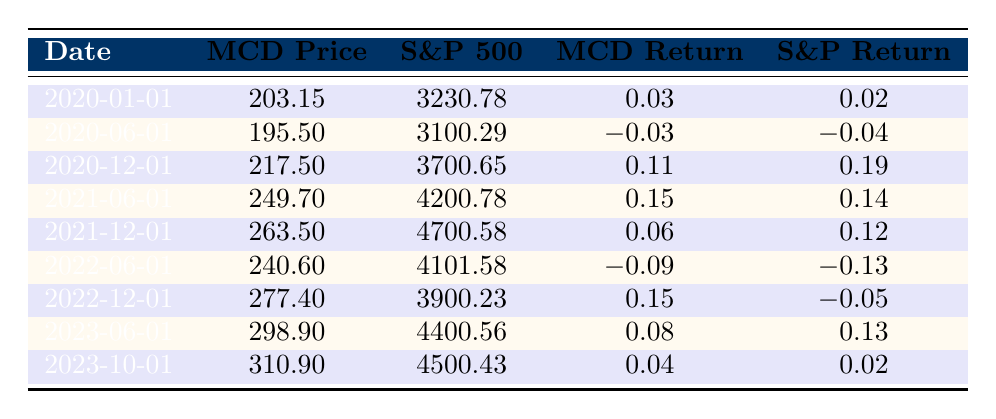What was the stock price of McDonald's on June 1, 2020? The table shows that McDonald's stock price on June 1, 2020, is listed under the respective date, which is 195.50.
Answer: 195.50 What was the S&P 500 index value on December 1, 2021? Looking at the table, the S&P 500 index value on December 1, 2021, is shown as 4700.58.
Answer: 4700.58 Between January 2020 and June 2021, which had a higher return, McDonald's or the S&P 500? For the relevant period, McDonald's returns were 0.03 (Jan 2020) and 0.15 (Jun 2021), while S&P returns were 0.02 and 0.14 respectively. McDonald's had higher returns in both instances.
Answer: McDonald's What was the difference in McDonald's stock price between December 1, 2020, and June 1, 2022? McDonald's stock prices were 217.50 on December 1, 2020, and 240.60 on June 1, 2022. The difference is 240.60 - 217.50 = 23.10.
Answer: 23.10 What was the average return of McDonald's from January 2020 to December 2022? The returns for the periods are: 0.03, -0.03, 0.11, 0.15, 0.06, -0.09, 0.15. Summing these gives 0.03 + (-0.03) + 0.11 + 0.15 + 0.06 + (-0.09) + 0.15 = 0.38. Dividing by the total periods (7) gives an average return of 0.38 / 7 = 0.0542857, approximately 0.05.
Answer: 0.05 Did McDonald's stock price consistently rise from June 2021 to October 2023? From the table, the prices show an increasing trend: 249.70 (June 2021), 263.50 (December 2021), 240.60 (June 2022 - a drop), 277.40 (December 2022), 298.90 (June 2023), 310.90 (October 2023). There was a drop in June 2022, indicating inconsistency.
Answer: No Which month had the highest percentage return for McDonald's stock? Calculating returns shows the highest return was on June 1, 2021, with 0.15 (15%). This is higher than the other monthly returns listed.
Answer: June 1, 2021 What was the total percentage change in McDonald's stock price from January 2020 to October 2023? The stock price increased from 203.15 in January 2020 to 310.90 in October 2023. The change in price is 310.90 - 203.15 = 107.75. The percentage change is (107.75 / 203.15) * 100 ≈ 52.97%.
Answer: 52.97% During which period did McDonald's stock experience a decline, and how much was the decline? The decline occurred from December 2021 (263.50) to June 2022 (240.60), indicating a decline of 263.50 - 240.60 = 22.90.
Answer: June 2022; 22.90 What was the return of the S&P 500 on June 1, 2020, compared to the previous period? On June 1, 2020, the S&P 500 return was -0.04, whereas the previous period (January 1, 2020) had a return of 0.02. This shows a decline in return.
Answer: Decline What overall trend do you observe for McDonald's returns from 2020 to 2023? Reviewing the returns, McDonald's experienced fluctuations: a positive start, a decline in mid-2022, and then regained upwards momentum towards late 2023. This suggests variability, but a recovery trend in recent years.
Answer: Fluctuations, with a recovery trend 